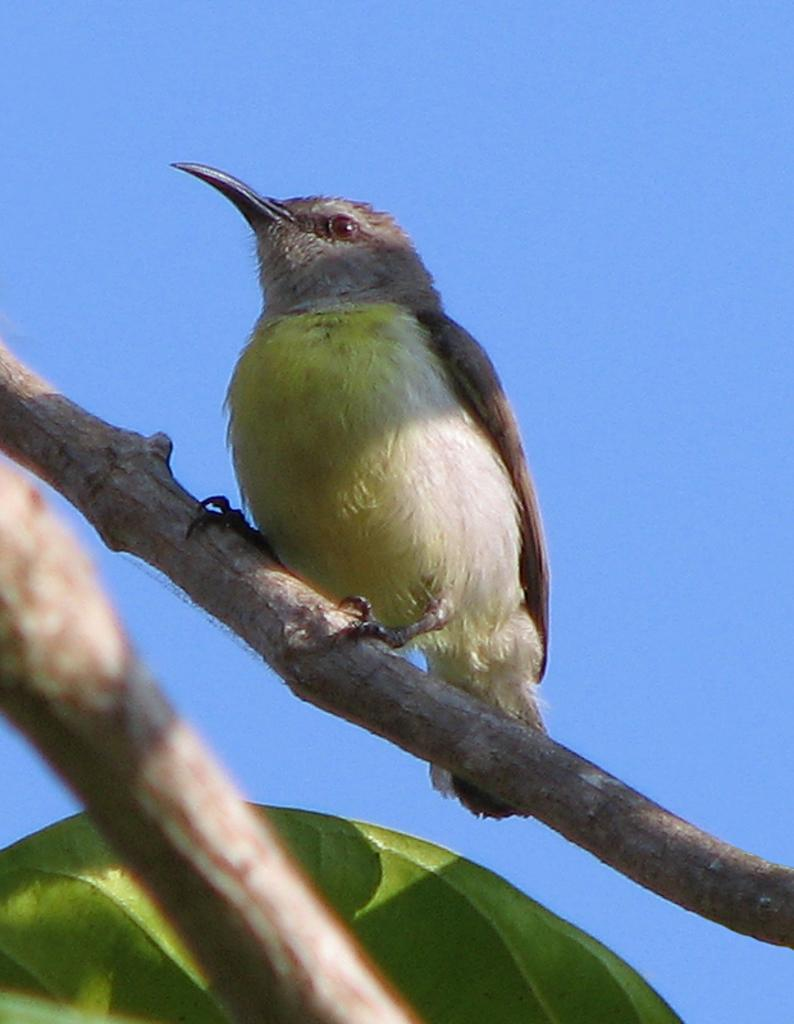What type of animal is in the image? There is a bird in the image. Where is the bird located? The bird is on a branch. What else can be seen at the bottom of the image? There is a leaf at the bottom of the image. What is visible in the background of the image? The sky is visible in the background of the image. What year is depicted in the image? The image does not depict a specific year; it is a photograph of a bird on a branch. 